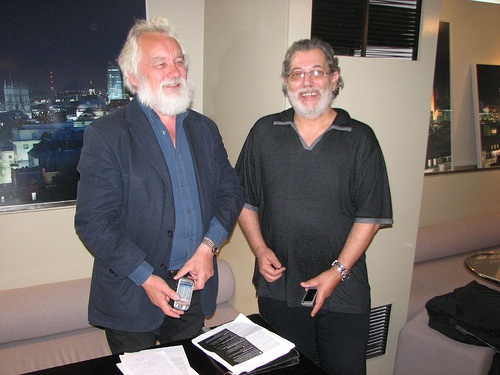Describe the objects in this image and their specific colors. I can see people in black, gray, and darkblue tones, people in black, gray, and lightpink tones, couch in black, darkgray, and gray tones, couch in black and gray tones, and handbag in black and gray tones in this image. 